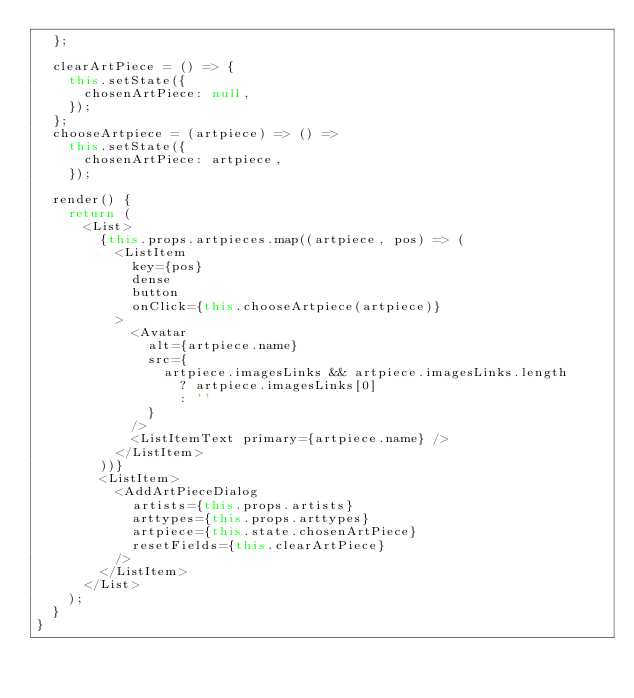<code> <loc_0><loc_0><loc_500><loc_500><_JavaScript_>  };

  clearArtPiece = () => {
    this.setState({
      chosenArtPiece: null,
    });
  };
  chooseArtpiece = (artpiece) => () =>
    this.setState({
      chosenArtPiece: artpiece,
    });

  render() {
    return (
      <List>
        {this.props.artpieces.map((artpiece, pos) => (
          <ListItem
            key={pos}
            dense
            button
            onClick={this.chooseArtpiece(artpiece)}
          >
            <Avatar
              alt={artpiece.name}
              src={
                artpiece.imagesLinks && artpiece.imagesLinks.length
                  ? artpiece.imagesLinks[0]
                  : ''
              }
            />
            <ListItemText primary={artpiece.name} />
          </ListItem>
        ))}
        <ListItem>
          <AddArtPieceDialog
            artists={this.props.artists}
            arttypes={this.props.arttypes}
            artpiece={this.state.chosenArtPiece}
            resetFields={this.clearArtPiece}
          />
        </ListItem>
      </List>
    );
  }
}
</code> 